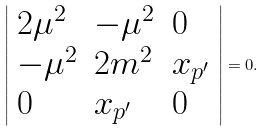<formula> <loc_0><loc_0><loc_500><loc_500>\left | \begin{array} { l l l l l } { { 2 \mu ^ { 2 } } } & { { - \mu ^ { 2 } } } & { 0 } \\ { { - \mu ^ { 2 } } } & { { 2 m ^ { 2 } } } & { { x _ { p ^ { \prime } } } } \\ { 0 } & { { x _ { p ^ { \prime } } } } & { 0 } \end{array} \right | = 0 .</formula> 